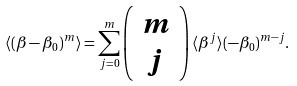<formula> <loc_0><loc_0><loc_500><loc_500>\langle ( \beta - \beta _ { 0 } ) ^ { m } \rangle = \sum _ { j = 0 } ^ { m } \left ( \begin{array} { c } m \\ j \end{array} \right ) \langle \beta ^ { j } \rangle ( - \beta _ { 0 } ) ^ { m - j } .</formula> 